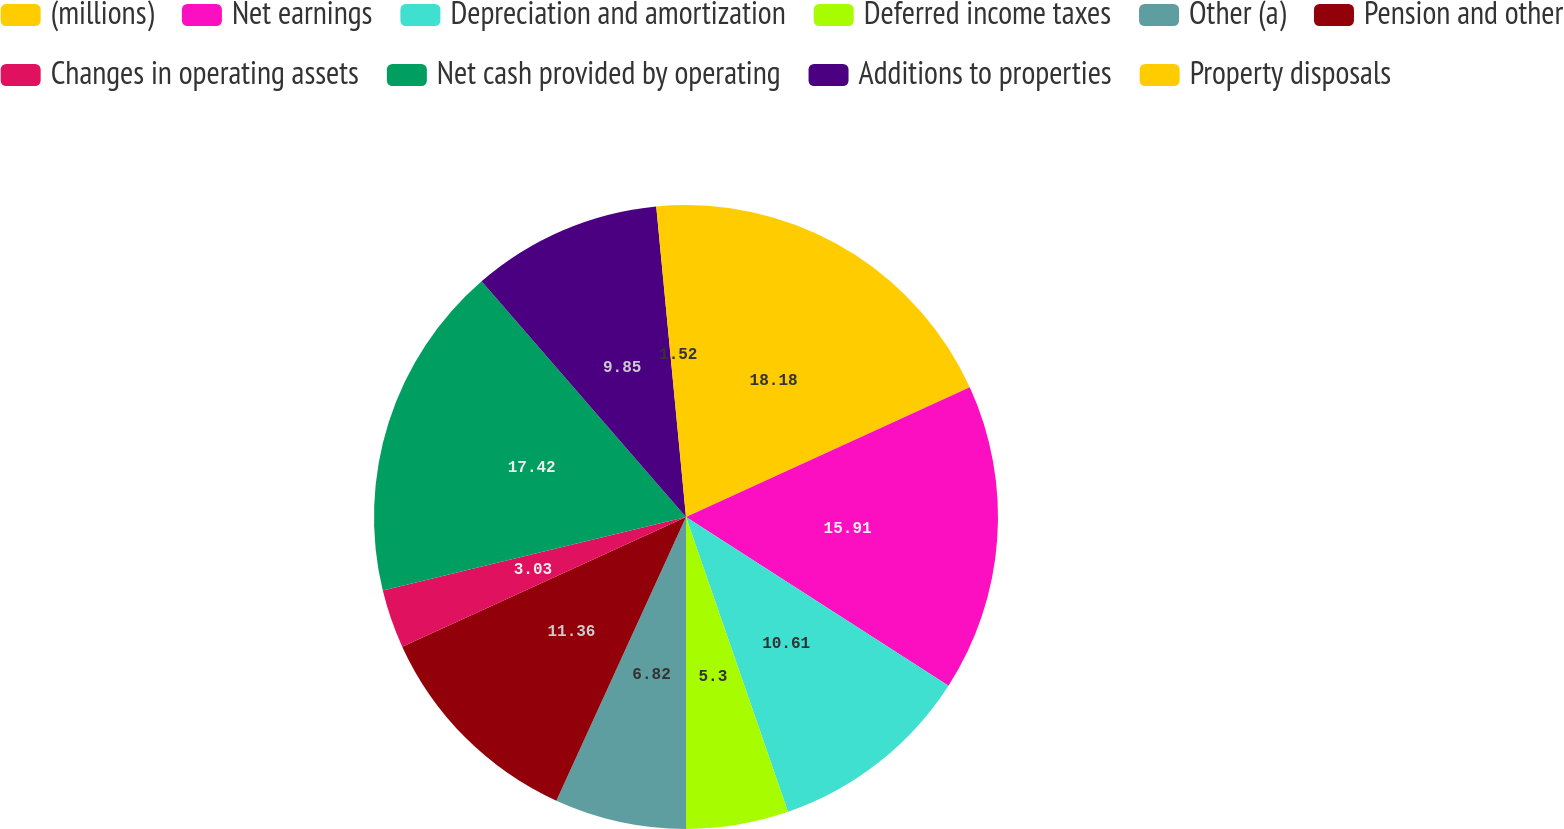<chart> <loc_0><loc_0><loc_500><loc_500><pie_chart><fcel>(millions)<fcel>Net earnings<fcel>Depreciation and amortization<fcel>Deferred income taxes<fcel>Other (a)<fcel>Pension and other<fcel>Changes in operating assets<fcel>Net cash provided by operating<fcel>Additions to properties<fcel>Property disposals<nl><fcel>18.18%<fcel>15.91%<fcel>10.61%<fcel>5.3%<fcel>6.82%<fcel>11.36%<fcel>3.03%<fcel>17.42%<fcel>9.85%<fcel>1.52%<nl></chart> 